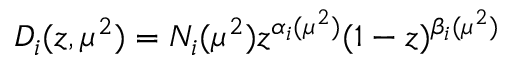Convert formula to latex. <formula><loc_0><loc_0><loc_500><loc_500>D _ { i } ( z , \mu ^ { 2 } ) = N _ { i } ( \mu ^ { 2 } ) z ^ { \alpha _ { i } ( \mu ^ { 2 } ) } ( 1 - z ) ^ { \beta _ { i } ( \mu ^ { 2 } ) }</formula> 